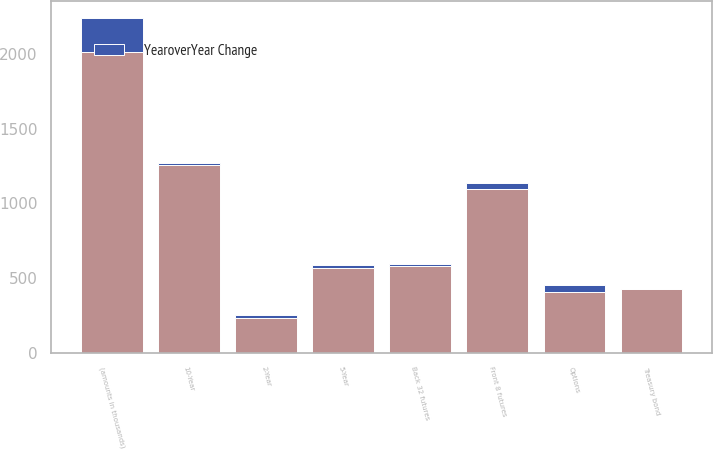Convert chart. <chart><loc_0><loc_0><loc_500><loc_500><stacked_bar_chart><ecel><fcel>(amounts in thousands)<fcel>Front 8 futures<fcel>Back 32 futures<fcel>Options<fcel>10-Year<fcel>5-Year<fcel>Treasury bond<fcel>2-Year<nl><fcel>nan<fcel>2012<fcel>1099<fcel>579<fcel>410<fcel>1255<fcel>567<fcel>427<fcel>230<nl><fcel>YearoverYear Change<fcel>230<fcel>36<fcel>13<fcel>47<fcel>14<fcel>21<fcel>3<fcel>22<nl></chart> 